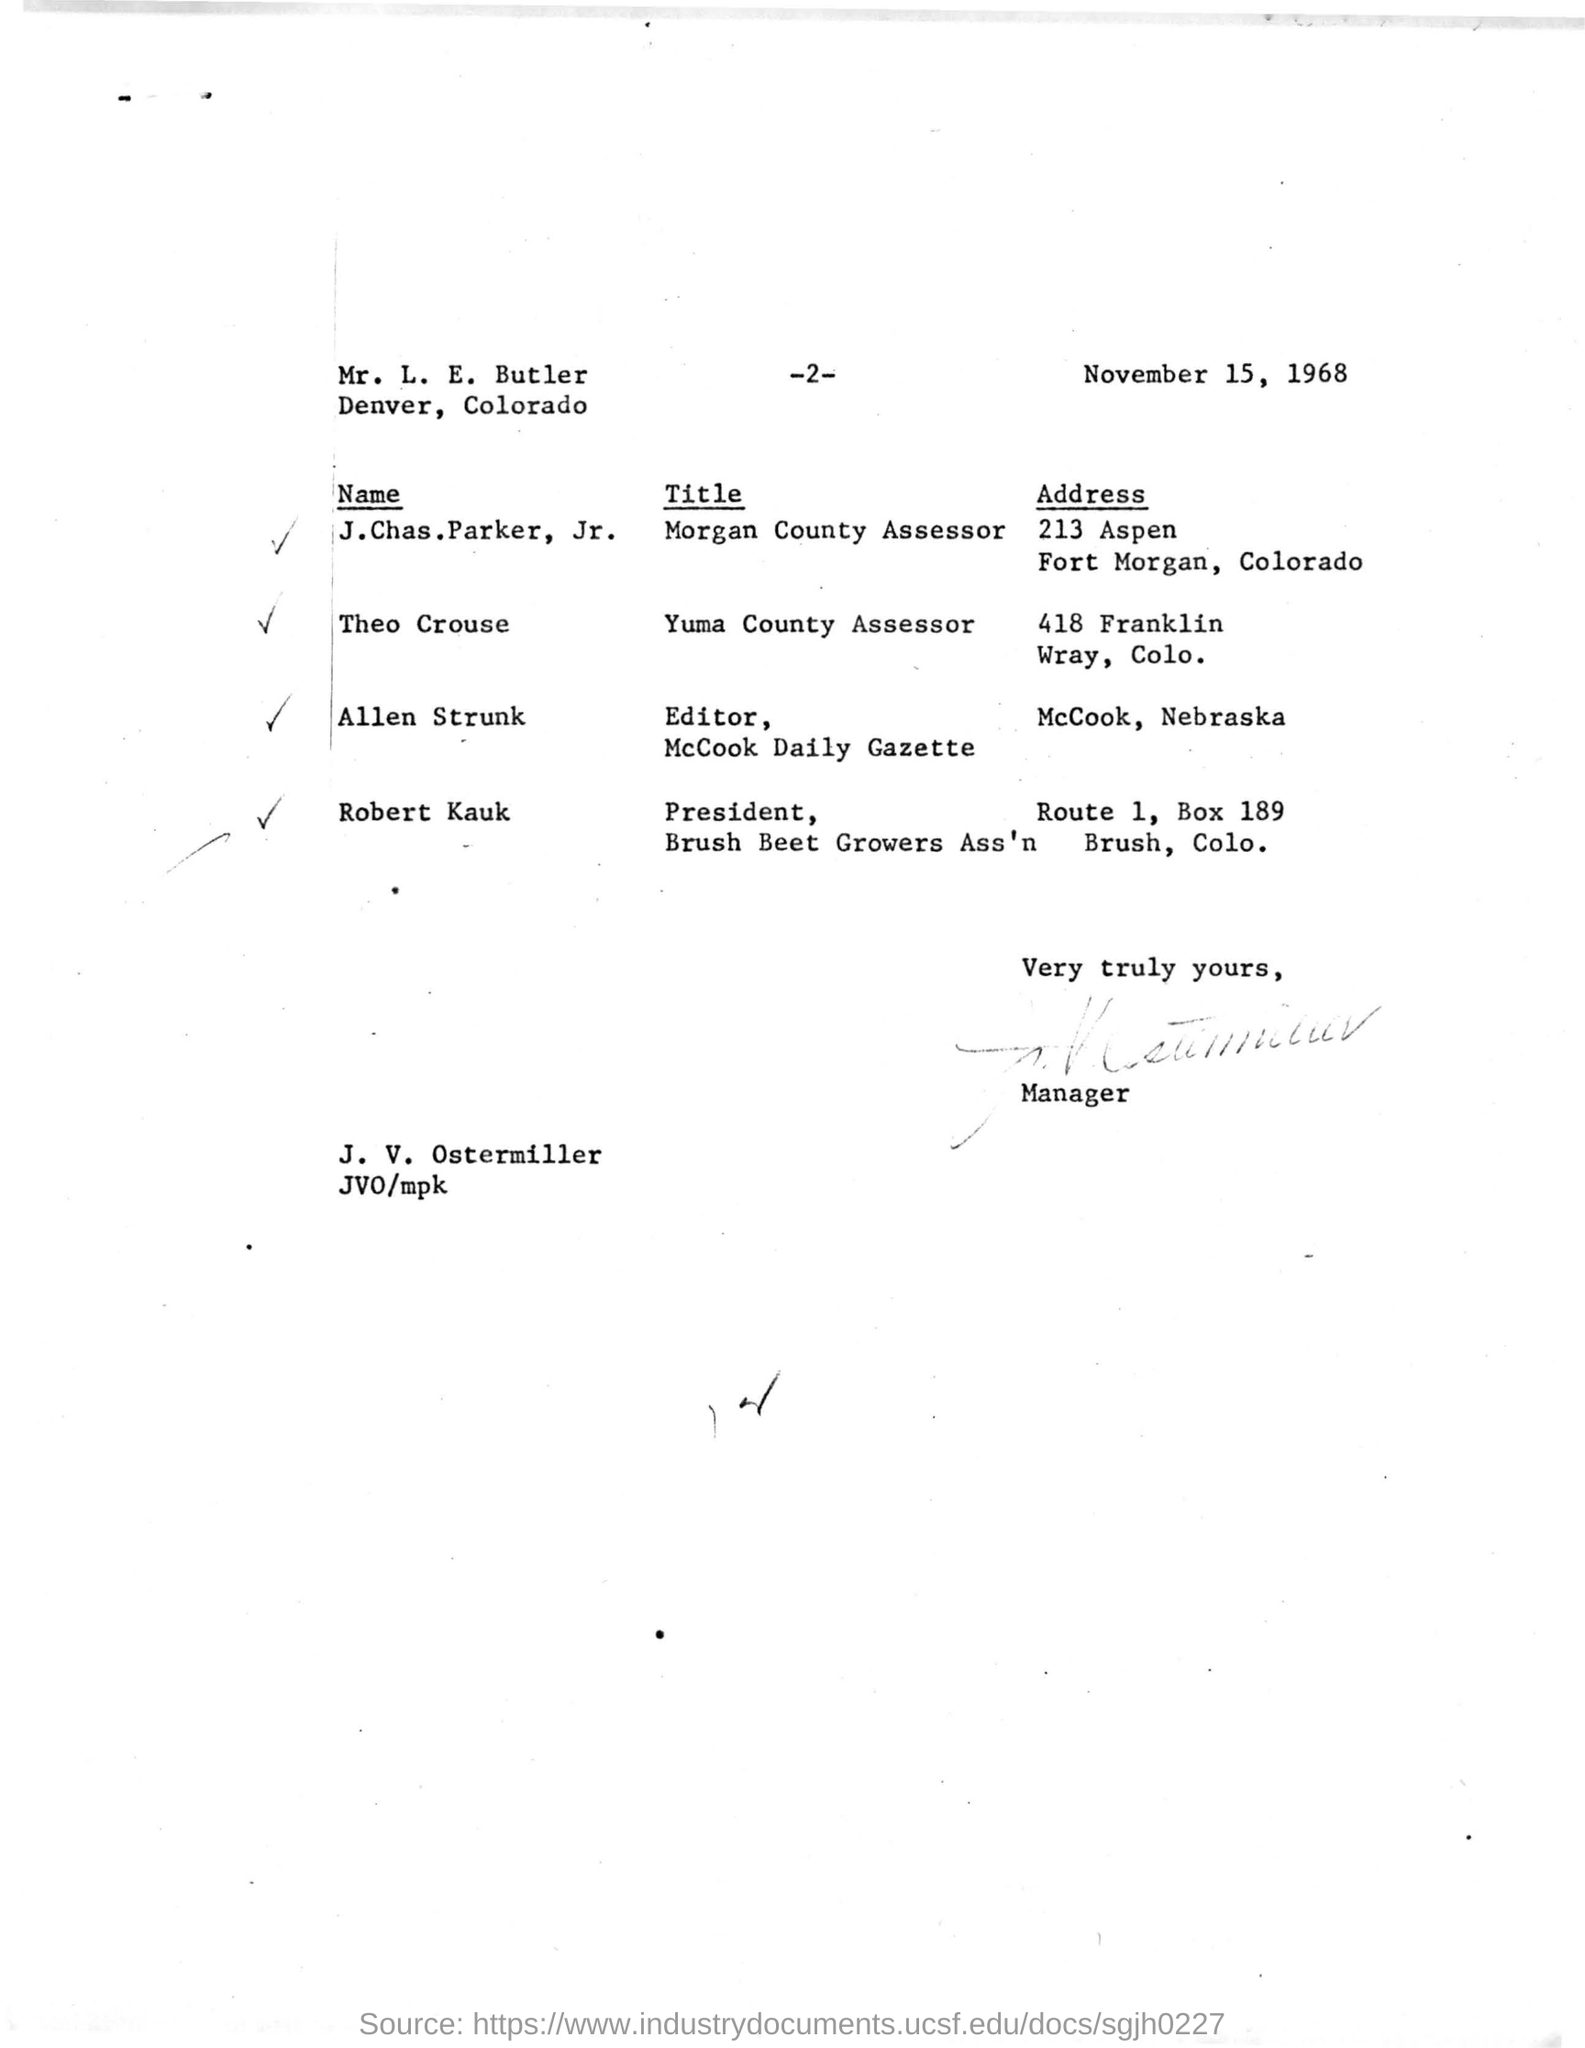Indicate a few pertinent items in this graphic. Robert Kauk's address is ROUTE 1, BOX 189 in BRUSH, COLORADO. The name "Allen Strunk" is associated with an address in McCook, Nebraska. The individual who holds the position of Yuma County Assessor is named THEO CROUSE. The person who signed the letter is the manager. The name Robert Kauk is President of the Brush Beet Growers Association. 